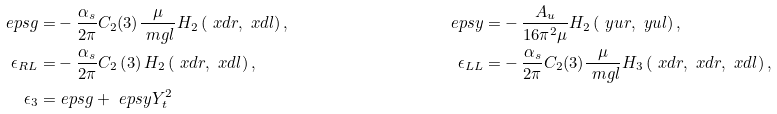Convert formula to latex. <formula><loc_0><loc_0><loc_500><loc_500>\ e p s g = & - \frac { \alpha _ { s } } { 2 \pi } C _ { 2 } ( 3 ) \frac { \mu } { \ m g l } H _ { 2 } \left ( \ x d r , \ x d l \right ) , & \ e p s y = & - \frac { A _ { u } } { 1 6 \pi ^ { 2 } \mu } H _ { 2 } \left ( \ y u r , \ y u l \right ) , \\ \epsilon _ { R L } = & - \frac { \alpha _ { s } } { 2 \pi } C _ { 2 } \left ( 3 \right ) H _ { 2 } \left ( \ x d r , \ x d l \right ) , & \epsilon _ { L L } = & - \frac { \alpha _ { s } } { 2 \pi } C _ { 2 } ( 3 ) \frac { \mu } { \ m g l } H _ { 3 } \left ( \ x d r , \ x d r , \ x d l \right ) , \\ \epsilon _ { 3 } = & \ e p s g + \ e p s y Y _ { t } ^ { 2 }</formula> 